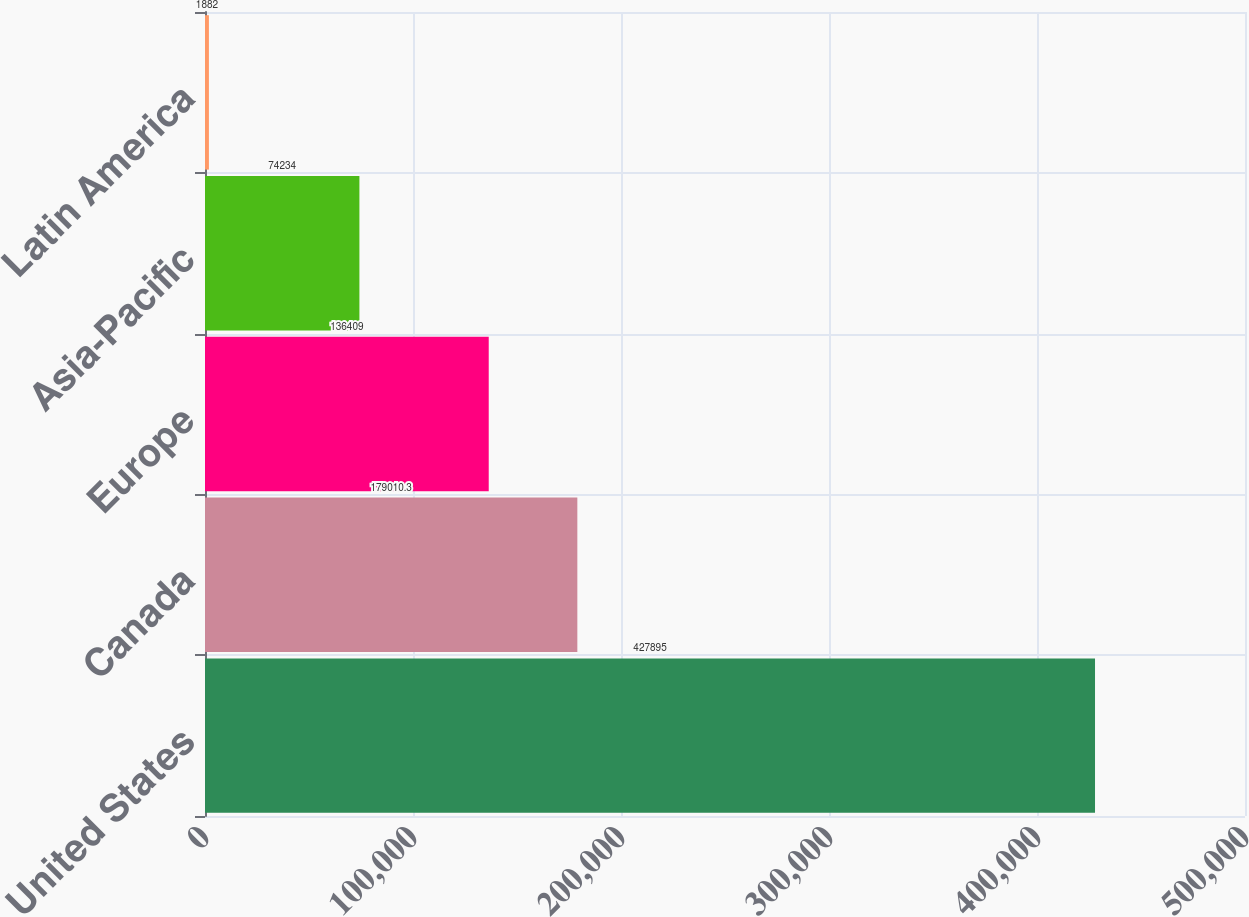<chart> <loc_0><loc_0><loc_500><loc_500><bar_chart><fcel>United States<fcel>Canada<fcel>Europe<fcel>Asia-Pacific<fcel>Latin America<nl><fcel>427895<fcel>179010<fcel>136409<fcel>74234<fcel>1882<nl></chart> 